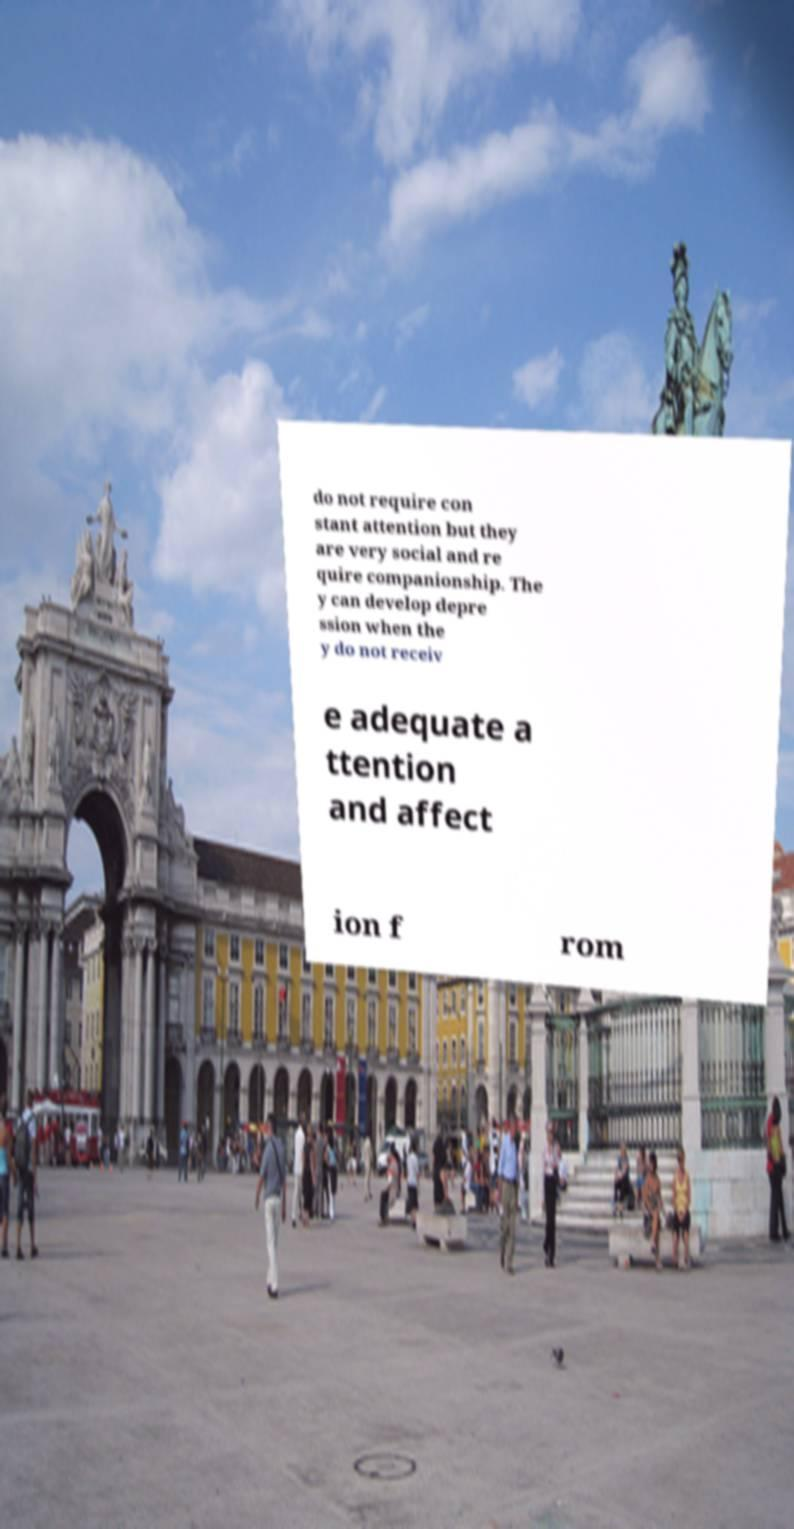What messages or text are displayed in this image? I need them in a readable, typed format. do not require con stant attention but they are very social and re quire companionship. The y can develop depre ssion when the y do not receiv e adequate a ttention and affect ion f rom 